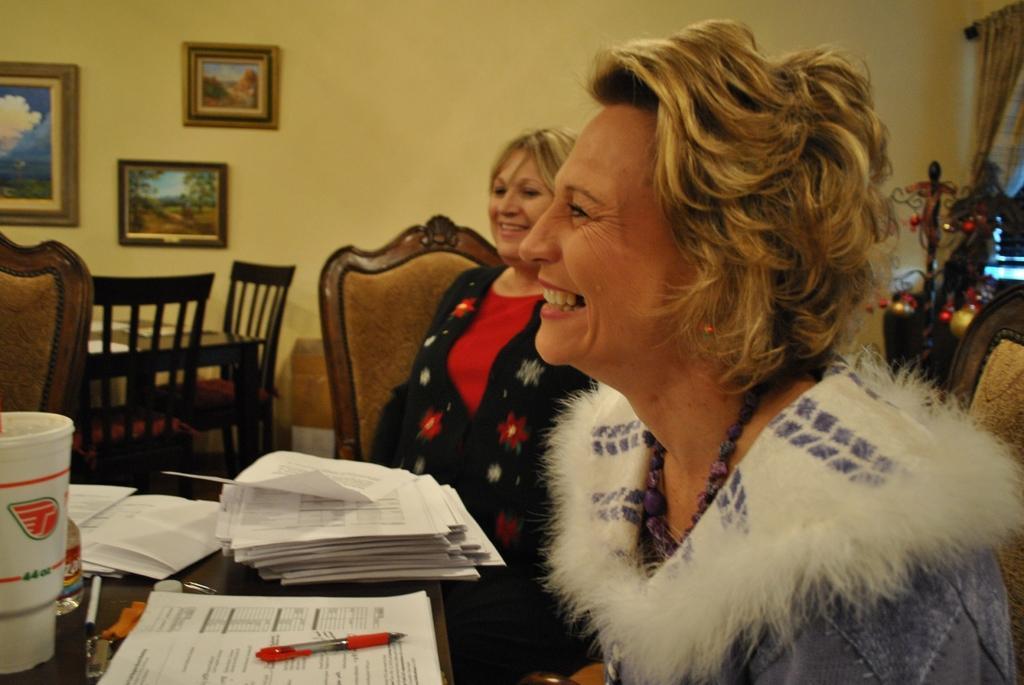Describe this image in one or two sentences. In this image there are two women sitting on chair. On top of table there are few papers and a pen on it. There is a glass and a bottle on table. There is a dining table and few chairs. Background of the image there is a wall on which three frames are fixed to it. Right side of image there is a christmas tree back to it there is a curtain. 